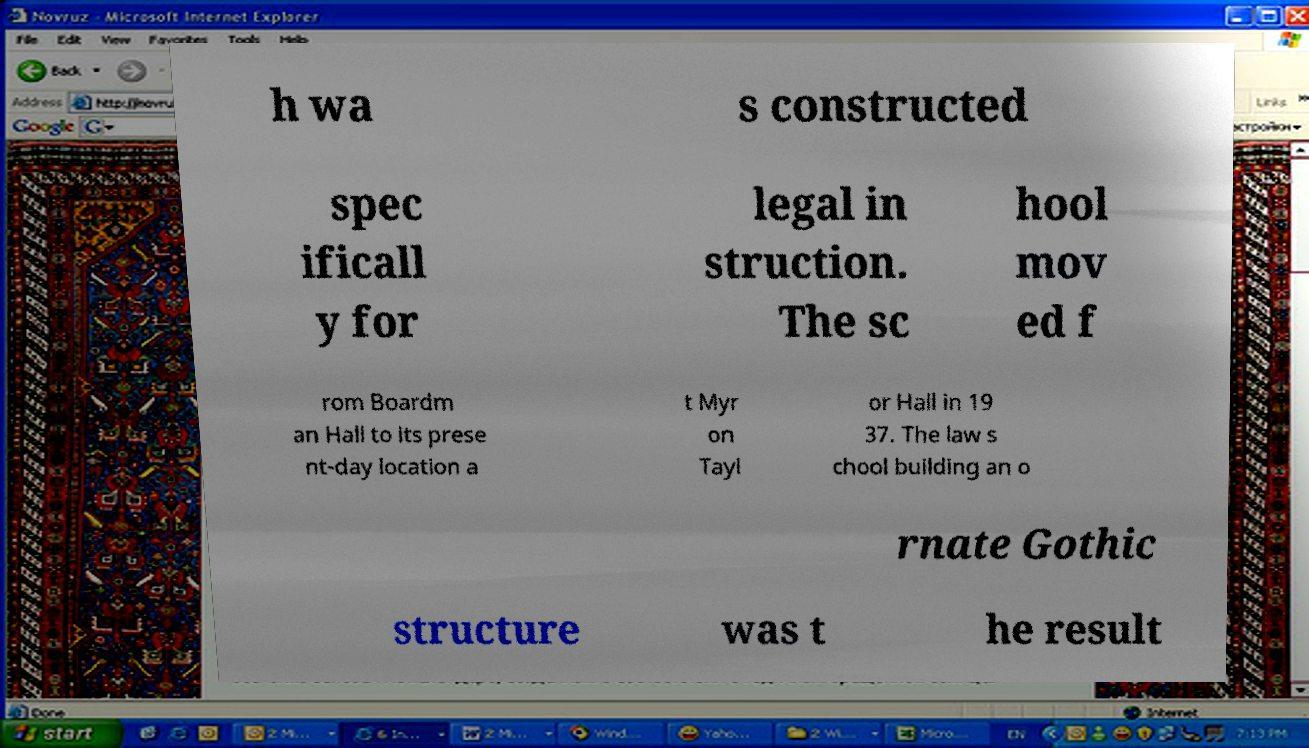There's text embedded in this image that I need extracted. Can you transcribe it verbatim? h wa s constructed spec ificall y for legal in struction. The sc hool mov ed f rom Boardm an Hall to its prese nt-day location a t Myr on Tayl or Hall in 19 37. The law s chool building an o rnate Gothic structure was t he result 